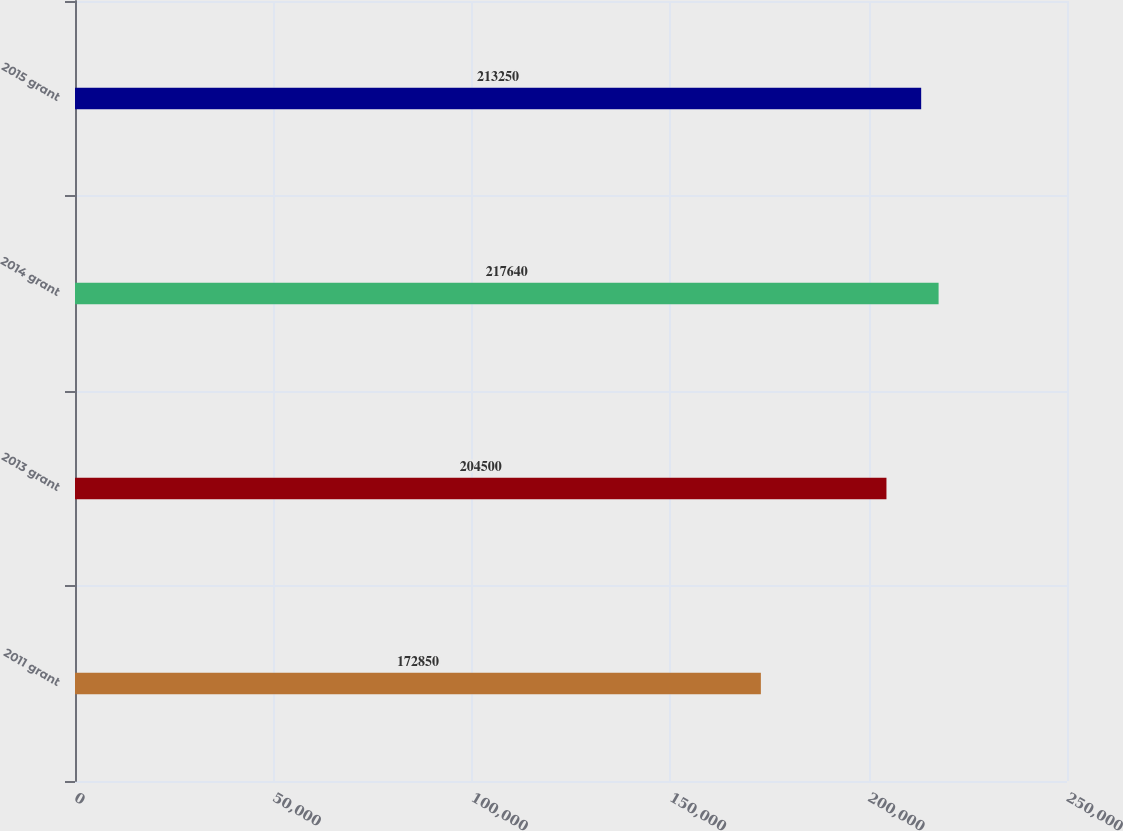<chart> <loc_0><loc_0><loc_500><loc_500><bar_chart><fcel>2011 grant<fcel>2013 grant<fcel>2014 grant<fcel>2015 grant<nl><fcel>172850<fcel>204500<fcel>217640<fcel>213250<nl></chart> 